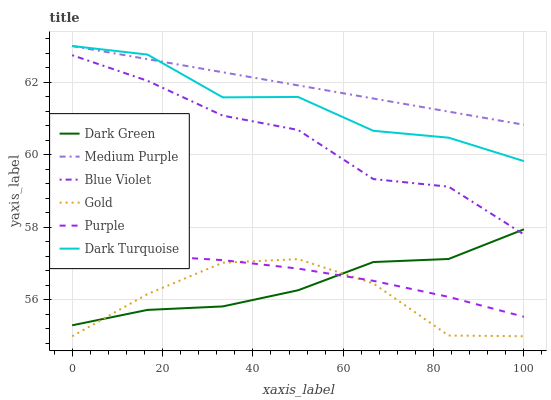Does Gold have the minimum area under the curve?
Answer yes or no. Yes. Does Medium Purple have the maximum area under the curve?
Answer yes or no. Yes. Does Purple have the minimum area under the curve?
Answer yes or no. No. Does Purple have the maximum area under the curve?
Answer yes or no. No. Is Medium Purple the smoothest?
Answer yes or no. Yes. Is Dark Turquoise the roughest?
Answer yes or no. Yes. Is Purple the smoothest?
Answer yes or no. No. Is Purple the roughest?
Answer yes or no. No. Does Gold have the lowest value?
Answer yes or no. Yes. Does Purple have the lowest value?
Answer yes or no. No. Does Medium Purple have the highest value?
Answer yes or no. Yes. Does Purple have the highest value?
Answer yes or no. No. Is Blue Violet less than Medium Purple?
Answer yes or no. Yes. Is Blue Violet greater than Gold?
Answer yes or no. Yes. Does Dark Green intersect Blue Violet?
Answer yes or no. Yes. Is Dark Green less than Blue Violet?
Answer yes or no. No. Is Dark Green greater than Blue Violet?
Answer yes or no. No. Does Blue Violet intersect Medium Purple?
Answer yes or no. No. 